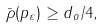Convert formula to latex. <formula><loc_0><loc_0><loc_500><loc_500>\bar { \rho } ( p _ { \varepsilon } ) \geq d _ { o } / 4 ,</formula> 